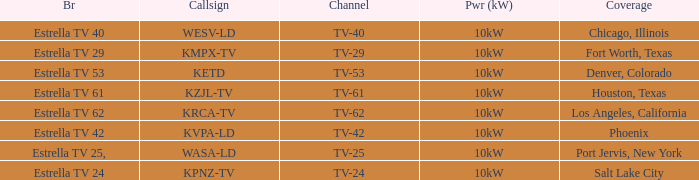List the branding for krca-tv. Estrella TV 62. 